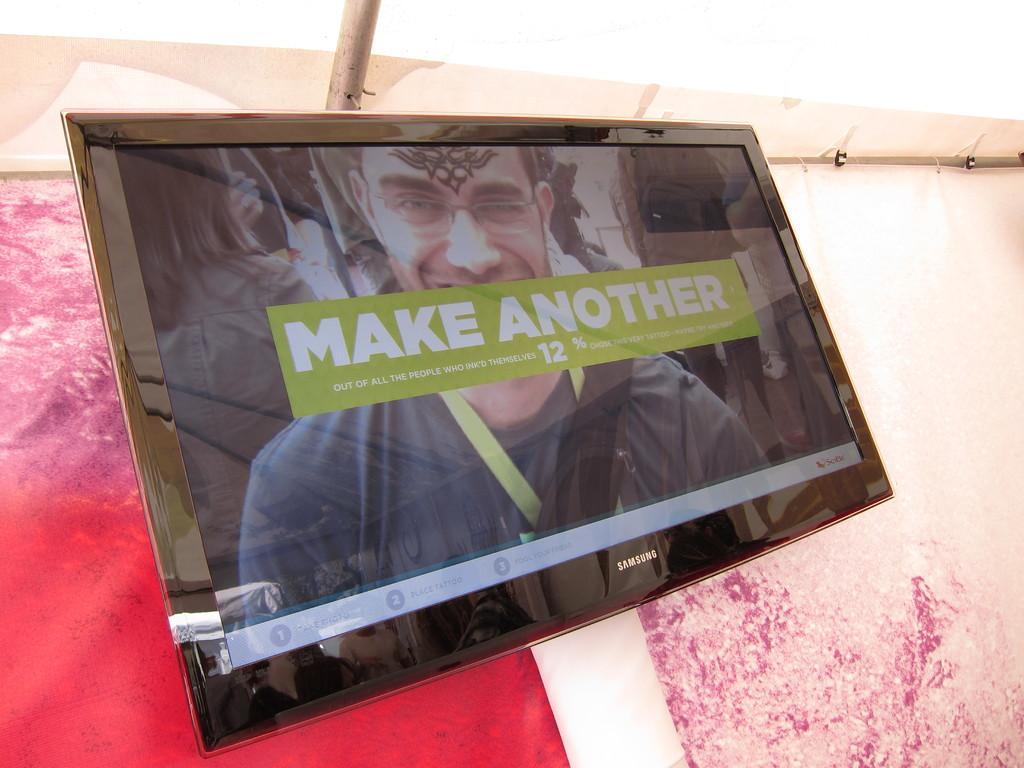Please provide a concise description of this image. In this image we can see television on a wall. On the screen we can see text and image of a person. 